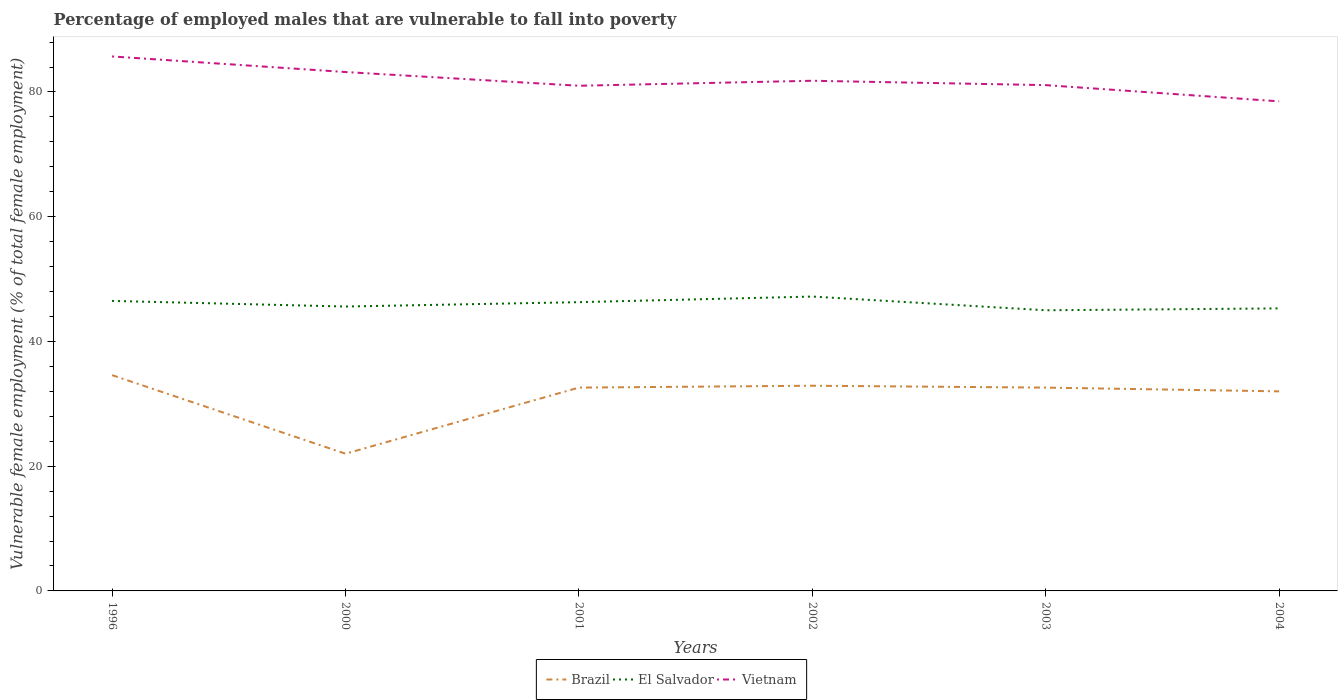How many different coloured lines are there?
Give a very brief answer. 3. Is the number of lines equal to the number of legend labels?
Ensure brevity in your answer.  Yes. In which year was the percentage of employed males who are vulnerable to fall into poverty in Brazil maximum?
Ensure brevity in your answer.  2000. What is the total percentage of employed males who are vulnerable to fall into poverty in Brazil in the graph?
Your answer should be very brief. -10.6. What is the difference between the highest and the second highest percentage of employed males who are vulnerable to fall into poverty in El Salvador?
Give a very brief answer. 2.2. What is the difference between the highest and the lowest percentage of employed males who are vulnerable to fall into poverty in El Salvador?
Provide a succinct answer. 3. How many lines are there?
Your answer should be very brief. 3. How many years are there in the graph?
Keep it short and to the point. 6. What is the difference between two consecutive major ticks on the Y-axis?
Your response must be concise. 20. Does the graph contain any zero values?
Your answer should be very brief. No. How many legend labels are there?
Ensure brevity in your answer.  3. How are the legend labels stacked?
Keep it short and to the point. Horizontal. What is the title of the graph?
Provide a short and direct response. Percentage of employed males that are vulnerable to fall into poverty. Does "Egypt, Arab Rep." appear as one of the legend labels in the graph?
Your answer should be compact. No. What is the label or title of the X-axis?
Provide a short and direct response. Years. What is the label or title of the Y-axis?
Offer a terse response. Vulnerable female employment (% of total female employment). What is the Vulnerable female employment (% of total female employment) of Brazil in 1996?
Your answer should be very brief. 34.6. What is the Vulnerable female employment (% of total female employment) of El Salvador in 1996?
Give a very brief answer. 46.5. What is the Vulnerable female employment (% of total female employment) in Vietnam in 1996?
Offer a terse response. 85.7. What is the Vulnerable female employment (% of total female employment) of Brazil in 2000?
Your answer should be very brief. 22. What is the Vulnerable female employment (% of total female employment) of El Salvador in 2000?
Your response must be concise. 45.6. What is the Vulnerable female employment (% of total female employment) of Vietnam in 2000?
Give a very brief answer. 83.2. What is the Vulnerable female employment (% of total female employment) of Brazil in 2001?
Provide a short and direct response. 32.6. What is the Vulnerable female employment (% of total female employment) in El Salvador in 2001?
Offer a terse response. 46.3. What is the Vulnerable female employment (% of total female employment) of Brazil in 2002?
Give a very brief answer. 32.9. What is the Vulnerable female employment (% of total female employment) of El Salvador in 2002?
Your answer should be compact. 47.2. What is the Vulnerable female employment (% of total female employment) of Vietnam in 2002?
Offer a very short reply. 81.8. What is the Vulnerable female employment (% of total female employment) of Brazil in 2003?
Provide a short and direct response. 32.6. What is the Vulnerable female employment (% of total female employment) in Vietnam in 2003?
Give a very brief answer. 81.1. What is the Vulnerable female employment (% of total female employment) in El Salvador in 2004?
Provide a short and direct response. 45.3. What is the Vulnerable female employment (% of total female employment) of Vietnam in 2004?
Offer a very short reply. 78.5. Across all years, what is the maximum Vulnerable female employment (% of total female employment) of Brazil?
Provide a succinct answer. 34.6. Across all years, what is the maximum Vulnerable female employment (% of total female employment) of El Salvador?
Your answer should be very brief. 47.2. Across all years, what is the maximum Vulnerable female employment (% of total female employment) in Vietnam?
Provide a short and direct response. 85.7. Across all years, what is the minimum Vulnerable female employment (% of total female employment) in Brazil?
Your answer should be compact. 22. Across all years, what is the minimum Vulnerable female employment (% of total female employment) of Vietnam?
Ensure brevity in your answer.  78.5. What is the total Vulnerable female employment (% of total female employment) in Brazil in the graph?
Make the answer very short. 186.7. What is the total Vulnerable female employment (% of total female employment) of El Salvador in the graph?
Your response must be concise. 275.9. What is the total Vulnerable female employment (% of total female employment) of Vietnam in the graph?
Give a very brief answer. 491.3. What is the difference between the Vulnerable female employment (% of total female employment) of Vietnam in 1996 and that in 2000?
Your answer should be compact. 2.5. What is the difference between the Vulnerable female employment (% of total female employment) of Vietnam in 1996 and that in 2001?
Give a very brief answer. 4.7. What is the difference between the Vulnerable female employment (% of total female employment) in Brazil in 1996 and that in 2002?
Provide a short and direct response. 1.7. What is the difference between the Vulnerable female employment (% of total female employment) in El Salvador in 1996 and that in 2003?
Your response must be concise. 1.5. What is the difference between the Vulnerable female employment (% of total female employment) of El Salvador in 1996 and that in 2004?
Give a very brief answer. 1.2. What is the difference between the Vulnerable female employment (% of total female employment) in El Salvador in 2000 and that in 2001?
Your response must be concise. -0.7. What is the difference between the Vulnerable female employment (% of total female employment) in Vietnam in 2000 and that in 2001?
Offer a terse response. 2.2. What is the difference between the Vulnerable female employment (% of total female employment) of Brazil in 2000 and that in 2002?
Keep it short and to the point. -10.9. What is the difference between the Vulnerable female employment (% of total female employment) in Vietnam in 2000 and that in 2002?
Offer a terse response. 1.4. What is the difference between the Vulnerable female employment (% of total female employment) of El Salvador in 2000 and that in 2003?
Make the answer very short. 0.6. What is the difference between the Vulnerable female employment (% of total female employment) of Vietnam in 2000 and that in 2003?
Offer a very short reply. 2.1. What is the difference between the Vulnerable female employment (% of total female employment) of Brazil in 2000 and that in 2004?
Your answer should be very brief. -10. What is the difference between the Vulnerable female employment (% of total female employment) in Brazil in 2001 and that in 2002?
Provide a succinct answer. -0.3. What is the difference between the Vulnerable female employment (% of total female employment) of Brazil in 2001 and that in 2003?
Offer a very short reply. 0. What is the difference between the Vulnerable female employment (% of total female employment) of El Salvador in 2001 and that in 2003?
Your response must be concise. 1.3. What is the difference between the Vulnerable female employment (% of total female employment) of El Salvador in 2001 and that in 2004?
Your answer should be very brief. 1. What is the difference between the Vulnerable female employment (% of total female employment) of El Salvador in 2002 and that in 2003?
Ensure brevity in your answer.  2.2. What is the difference between the Vulnerable female employment (% of total female employment) of El Salvador in 2002 and that in 2004?
Your answer should be compact. 1.9. What is the difference between the Vulnerable female employment (% of total female employment) in Vietnam in 2002 and that in 2004?
Ensure brevity in your answer.  3.3. What is the difference between the Vulnerable female employment (% of total female employment) in Brazil in 2003 and that in 2004?
Provide a short and direct response. 0.6. What is the difference between the Vulnerable female employment (% of total female employment) of Brazil in 1996 and the Vulnerable female employment (% of total female employment) of El Salvador in 2000?
Give a very brief answer. -11. What is the difference between the Vulnerable female employment (% of total female employment) of Brazil in 1996 and the Vulnerable female employment (% of total female employment) of Vietnam in 2000?
Offer a very short reply. -48.6. What is the difference between the Vulnerable female employment (% of total female employment) in El Salvador in 1996 and the Vulnerable female employment (% of total female employment) in Vietnam in 2000?
Offer a terse response. -36.7. What is the difference between the Vulnerable female employment (% of total female employment) in Brazil in 1996 and the Vulnerable female employment (% of total female employment) in Vietnam in 2001?
Keep it short and to the point. -46.4. What is the difference between the Vulnerable female employment (% of total female employment) of El Salvador in 1996 and the Vulnerable female employment (% of total female employment) of Vietnam in 2001?
Give a very brief answer. -34.5. What is the difference between the Vulnerable female employment (% of total female employment) of Brazil in 1996 and the Vulnerable female employment (% of total female employment) of El Salvador in 2002?
Make the answer very short. -12.6. What is the difference between the Vulnerable female employment (% of total female employment) in Brazil in 1996 and the Vulnerable female employment (% of total female employment) in Vietnam in 2002?
Make the answer very short. -47.2. What is the difference between the Vulnerable female employment (% of total female employment) of El Salvador in 1996 and the Vulnerable female employment (% of total female employment) of Vietnam in 2002?
Provide a short and direct response. -35.3. What is the difference between the Vulnerable female employment (% of total female employment) in Brazil in 1996 and the Vulnerable female employment (% of total female employment) in El Salvador in 2003?
Provide a succinct answer. -10.4. What is the difference between the Vulnerable female employment (% of total female employment) of Brazil in 1996 and the Vulnerable female employment (% of total female employment) of Vietnam in 2003?
Provide a succinct answer. -46.5. What is the difference between the Vulnerable female employment (% of total female employment) in El Salvador in 1996 and the Vulnerable female employment (% of total female employment) in Vietnam in 2003?
Make the answer very short. -34.6. What is the difference between the Vulnerable female employment (% of total female employment) in Brazil in 1996 and the Vulnerable female employment (% of total female employment) in Vietnam in 2004?
Offer a very short reply. -43.9. What is the difference between the Vulnerable female employment (% of total female employment) of El Salvador in 1996 and the Vulnerable female employment (% of total female employment) of Vietnam in 2004?
Offer a terse response. -32. What is the difference between the Vulnerable female employment (% of total female employment) in Brazil in 2000 and the Vulnerable female employment (% of total female employment) in El Salvador in 2001?
Your answer should be compact. -24.3. What is the difference between the Vulnerable female employment (% of total female employment) of Brazil in 2000 and the Vulnerable female employment (% of total female employment) of Vietnam in 2001?
Keep it short and to the point. -59. What is the difference between the Vulnerable female employment (% of total female employment) in El Salvador in 2000 and the Vulnerable female employment (% of total female employment) in Vietnam in 2001?
Give a very brief answer. -35.4. What is the difference between the Vulnerable female employment (% of total female employment) of Brazil in 2000 and the Vulnerable female employment (% of total female employment) of El Salvador in 2002?
Your answer should be compact. -25.2. What is the difference between the Vulnerable female employment (% of total female employment) of Brazil in 2000 and the Vulnerable female employment (% of total female employment) of Vietnam in 2002?
Your answer should be compact. -59.8. What is the difference between the Vulnerable female employment (% of total female employment) of El Salvador in 2000 and the Vulnerable female employment (% of total female employment) of Vietnam in 2002?
Give a very brief answer. -36.2. What is the difference between the Vulnerable female employment (% of total female employment) in Brazil in 2000 and the Vulnerable female employment (% of total female employment) in Vietnam in 2003?
Offer a very short reply. -59.1. What is the difference between the Vulnerable female employment (% of total female employment) in El Salvador in 2000 and the Vulnerable female employment (% of total female employment) in Vietnam in 2003?
Keep it short and to the point. -35.5. What is the difference between the Vulnerable female employment (% of total female employment) of Brazil in 2000 and the Vulnerable female employment (% of total female employment) of El Salvador in 2004?
Keep it short and to the point. -23.3. What is the difference between the Vulnerable female employment (% of total female employment) in Brazil in 2000 and the Vulnerable female employment (% of total female employment) in Vietnam in 2004?
Provide a short and direct response. -56.5. What is the difference between the Vulnerable female employment (% of total female employment) of El Salvador in 2000 and the Vulnerable female employment (% of total female employment) of Vietnam in 2004?
Keep it short and to the point. -32.9. What is the difference between the Vulnerable female employment (% of total female employment) in Brazil in 2001 and the Vulnerable female employment (% of total female employment) in El Salvador in 2002?
Provide a short and direct response. -14.6. What is the difference between the Vulnerable female employment (% of total female employment) of Brazil in 2001 and the Vulnerable female employment (% of total female employment) of Vietnam in 2002?
Provide a succinct answer. -49.2. What is the difference between the Vulnerable female employment (% of total female employment) in El Salvador in 2001 and the Vulnerable female employment (% of total female employment) in Vietnam in 2002?
Your response must be concise. -35.5. What is the difference between the Vulnerable female employment (% of total female employment) of Brazil in 2001 and the Vulnerable female employment (% of total female employment) of El Salvador in 2003?
Provide a succinct answer. -12.4. What is the difference between the Vulnerable female employment (% of total female employment) of Brazil in 2001 and the Vulnerable female employment (% of total female employment) of Vietnam in 2003?
Provide a short and direct response. -48.5. What is the difference between the Vulnerable female employment (% of total female employment) in El Salvador in 2001 and the Vulnerable female employment (% of total female employment) in Vietnam in 2003?
Your answer should be very brief. -34.8. What is the difference between the Vulnerable female employment (% of total female employment) in Brazil in 2001 and the Vulnerable female employment (% of total female employment) in El Salvador in 2004?
Offer a terse response. -12.7. What is the difference between the Vulnerable female employment (% of total female employment) of Brazil in 2001 and the Vulnerable female employment (% of total female employment) of Vietnam in 2004?
Ensure brevity in your answer.  -45.9. What is the difference between the Vulnerable female employment (% of total female employment) of El Salvador in 2001 and the Vulnerable female employment (% of total female employment) of Vietnam in 2004?
Provide a short and direct response. -32.2. What is the difference between the Vulnerable female employment (% of total female employment) in Brazil in 2002 and the Vulnerable female employment (% of total female employment) in Vietnam in 2003?
Provide a succinct answer. -48.2. What is the difference between the Vulnerable female employment (% of total female employment) of El Salvador in 2002 and the Vulnerable female employment (% of total female employment) of Vietnam in 2003?
Ensure brevity in your answer.  -33.9. What is the difference between the Vulnerable female employment (% of total female employment) of Brazil in 2002 and the Vulnerable female employment (% of total female employment) of El Salvador in 2004?
Offer a very short reply. -12.4. What is the difference between the Vulnerable female employment (% of total female employment) in Brazil in 2002 and the Vulnerable female employment (% of total female employment) in Vietnam in 2004?
Provide a succinct answer. -45.6. What is the difference between the Vulnerable female employment (% of total female employment) in El Salvador in 2002 and the Vulnerable female employment (% of total female employment) in Vietnam in 2004?
Your response must be concise. -31.3. What is the difference between the Vulnerable female employment (% of total female employment) of Brazil in 2003 and the Vulnerable female employment (% of total female employment) of El Salvador in 2004?
Your answer should be very brief. -12.7. What is the difference between the Vulnerable female employment (% of total female employment) in Brazil in 2003 and the Vulnerable female employment (% of total female employment) in Vietnam in 2004?
Keep it short and to the point. -45.9. What is the difference between the Vulnerable female employment (% of total female employment) in El Salvador in 2003 and the Vulnerable female employment (% of total female employment) in Vietnam in 2004?
Your answer should be very brief. -33.5. What is the average Vulnerable female employment (% of total female employment) in Brazil per year?
Your answer should be very brief. 31.12. What is the average Vulnerable female employment (% of total female employment) of El Salvador per year?
Offer a terse response. 45.98. What is the average Vulnerable female employment (% of total female employment) in Vietnam per year?
Your answer should be compact. 81.88. In the year 1996, what is the difference between the Vulnerable female employment (% of total female employment) in Brazil and Vulnerable female employment (% of total female employment) in Vietnam?
Provide a succinct answer. -51.1. In the year 1996, what is the difference between the Vulnerable female employment (% of total female employment) in El Salvador and Vulnerable female employment (% of total female employment) in Vietnam?
Provide a succinct answer. -39.2. In the year 2000, what is the difference between the Vulnerable female employment (% of total female employment) in Brazil and Vulnerable female employment (% of total female employment) in El Salvador?
Ensure brevity in your answer.  -23.6. In the year 2000, what is the difference between the Vulnerable female employment (% of total female employment) of Brazil and Vulnerable female employment (% of total female employment) of Vietnam?
Make the answer very short. -61.2. In the year 2000, what is the difference between the Vulnerable female employment (% of total female employment) of El Salvador and Vulnerable female employment (% of total female employment) of Vietnam?
Offer a very short reply. -37.6. In the year 2001, what is the difference between the Vulnerable female employment (% of total female employment) in Brazil and Vulnerable female employment (% of total female employment) in El Salvador?
Keep it short and to the point. -13.7. In the year 2001, what is the difference between the Vulnerable female employment (% of total female employment) of Brazil and Vulnerable female employment (% of total female employment) of Vietnam?
Offer a terse response. -48.4. In the year 2001, what is the difference between the Vulnerable female employment (% of total female employment) of El Salvador and Vulnerable female employment (% of total female employment) of Vietnam?
Offer a terse response. -34.7. In the year 2002, what is the difference between the Vulnerable female employment (% of total female employment) in Brazil and Vulnerable female employment (% of total female employment) in El Salvador?
Provide a succinct answer. -14.3. In the year 2002, what is the difference between the Vulnerable female employment (% of total female employment) in Brazil and Vulnerable female employment (% of total female employment) in Vietnam?
Keep it short and to the point. -48.9. In the year 2002, what is the difference between the Vulnerable female employment (% of total female employment) of El Salvador and Vulnerable female employment (% of total female employment) of Vietnam?
Offer a terse response. -34.6. In the year 2003, what is the difference between the Vulnerable female employment (% of total female employment) in Brazil and Vulnerable female employment (% of total female employment) in El Salvador?
Provide a short and direct response. -12.4. In the year 2003, what is the difference between the Vulnerable female employment (% of total female employment) of Brazil and Vulnerable female employment (% of total female employment) of Vietnam?
Make the answer very short. -48.5. In the year 2003, what is the difference between the Vulnerable female employment (% of total female employment) of El Salvador and Vulnerable female employment (% of total female employment) of Vietnam?
Your answer should be very brief. -36.1. In the year 2004, what is the difference between the Vulnerable female employment (% of total female employment) of Brazil and Vulnerable female employment (% of total female employment) of Vietnam?
Your answer should be compact. -46.5. In the year 2004, what is the difference between the Vulnerable female employment (% of total female employment) in El Salvador and Vulnerable female employment (% of total female employment) in Vietnam?
Offer a very short reply. -33.2. What is the ratio of the Vulnerable female employment (% of total female employment) in Brazil in 1996 to that in 2000?
Provide a succinct answer. 1.57. What is the ratio of the Vulnerable female employment (% of total female employment) of El Salvador in 1996 to that in 2000?
Provide a succinct answer. 1.02. What is the ratio of the Vulnerable female employment (% of total female employment) of Vietnam in 1996 to that in 2000?
Offer a terse response. 1.03. What is the ratio of the Vulnerable female employment (% of total female employment) of Brazil in 1996 to that in 2001?
Ensure brevity in your answer.  1.06. What is the ratio of the Vulnerable female employment (% of total female employment) in Vietnam in 1996 to that in 2001?
Your answer should be compact. 1.06. What is the ratio of the Vulnerable female employment (% of total female employment) of Brazil in 1996 to that in 2002?
Ensure brevity in your answer.  1.05. What is the ratio of the Vulnerable female employment (% of total female employment) of El Salvador in 1996 to that in 2002?
Your response must be concise. 0.99. What is the ratio of the Vulnerable female employment (% of total female employment) of Vietnam in 1996 to that in 2002?
Provide a succinct answer. 1.05. What is the ratio of the Vulnerable female employment (% of total female employment) of Brazil in 1996 to that in 2003?
Offer a terse response. 1.06. What is the ratio of the Vulnerable female employment (% of total female employment) in El Salvador in 1996 to that in 2003?
Keep it short and to the point. 1.03. What is the ratio of the Vulnerable female employment (% of total female employment) of Vietnam in 1996 to that in 2003?
Offer a terse response. 1.06. What is the ratio of the Vulnerable female employment (% of total female employment) in Brazil in 1996 to that in 2004?
Offer a terse response. 1.08. What is the ratio of the Vulnerable female employment (% of total female employment) in El Salvador in 1996 to that in 2004?
Provide a succinct answer. 1.03. What is the ratio of the Vulnerable female employment (% of total female employment) in Vietnam in 1996 to that in 2004?
Your answer should be compact. 1.09. What is the ratio of the Vulnerable female employment (% of total female employment) of Brazil in 2000 to that in 2001?
Offer a very short reply. 0.67. What is the ratio of the Vulnerable female employment (% of total female employment) in El Salvador in 2000 to that in 2001?
Make the answer very short. 0.98. What is the ratio of the Vulnerable female employment (% of total female employment) in Vietnam in 2000 to that in 2001?
Provide a succinct answer. 1.03. What is the ratio of the Vulnerable female employment (% of total female employment) of Brazil in 2000 to that in 2002?
Offer a terse response. 0.67. What is the ratio of the Vulnerable female employment (% of total female employment) in El Salvador in 2000 to that in 2002?
Your answer should be compact. 0.97. What is the ratio of the Vulnerable female employment (% of total female employment) of Vietnam in 2000 to that in 2002?
Offer a terse response. 1.02. What is the ratio of the Vulnerable female employment (% of total female employment) of Brazil in 2000 to that in 2003?
Ensure brevity in your answer.  0.67. What is the ratio of the Vulnerable female employment (% of total female employment) of El Salvador in 2000 to that in 2003?
Ensure brevity in your answer.  1.01. What is the ratio of the Vulnerable female employment (% of total female employment) in Vietnam in 2000 to that in 2003?
Offer a terse response. 1.03. What is the ratio of the Vulnerable female employment (% of total female employment) in Brazil in 2000 to that in 2004?
Keep it short and to the point. 0.69. What is the ratio of the Vulnerable female employment (% of total female employment) of El Salvador in 2000 to that in 2004?
Provide a succinct answer. 1.01. What is the ratio of the Vulnerable female employment (% of total female employment) of Vietnam in 2000 to that in 2004?
Provide a succinct answer. 1.06. What is the ratio of the Vulnerable female employment (% of total female employment) of Brazil in 2001 to that in 2002?
Ensure brevity in your answer.  0.99. What is the ratio of the Vulnerable female employment (% of total female employment) in El Salvador in 2001 to that in 2002?
Make the answer very short. 0.98. What is the ratio of the Vulnerable female employment (% of total female employment) of Vietnam in 2001 to that in 2002?
Make the answer very short. 0.99. What is the ratio of the Vulnerable female employment (% of total female employment) in Brazil in 2001 to that in 2003?
Provide a short and direct response. 1. What is the ratio of the Vulnerable female employment (% of total female employment) of El Salvador in 2001 to that in 2003?
Your response must be concise. 1.03. What is the ratio of the Vulnerable female employment (% of total female employment) of Vietnam in 2001 to that in 2003?
Your answer should be very brief. 1. What is the ratio of the Vulnerable female employment (% of total female employment) of Brazil in 2001 to that in 2004?
Give a very brief answer. 1.02. What is the ratio of the Vulnerable female employment (% of total female employment) in El Salvador in 2001 to that in 2004?
Provide a succinct answer. 1.02. What is the ratio of the Vulnerable female employment (% of total female employment) of Vietnam in 2001 to that in 2004?
Provide a succinct answer. 1.03. What is the ratio of the Vulnerable female employment (% of total female employment) of Brazil in 2002 to that in 2003?
Provide a succinct answer. 1.01. What is the ratio of the Vulnerable female employment (% of total female employment) of El Salvador in 2002 to that in 2003?
Your response must be concise. 1.05. What is the ratio of the Vulnerable female employment (% of total female employment) in Vietnam in 2002 to that in 2003?
Your answer should be very brief. 1.01. What is the ratio of the Vulnerable female employment (% of total female employment) in Brazil in 2002 to that in 2004?
Your response must be concise. 1.03. What is the ratio of the Vulnerable female employment (% of total female employment) in El Salvador in 2002 to that in 2004?
Offer a very short reply. 1.04. What is the ratio of the Vulnerable female employment (% of total female employment) in Vietnam in 2002 to that in 2004?
Keep it short and to the point. 1.04. What is the ratio of the Vulnerable female employment (% of total female employment) in Brazil in 2003 to that in 2004?
Ensure brevity in your answer.  1.02. What is the ratio of the Vulnerable female employment (% of total female employment) of El Salvador in 2003 to that in 2004?
Provide a succinct answer. 0.99. What is the ratio of the Vulnerable female employment (% of total female employment) of Vietnam in 2003 to that in 2004?
Make the answer very short. 1.03. What is the difference between the highest and the second highest Vulnerable female employment (% of total female employment) in El Salvador?
Your answer should be compact. 0.7. What is the difference between the highest and the lowest Vulnerable female employment (% of total female employment) of Brazil?
Your answer should be very brief. 12.6. What is the difference between the highest and the lowest Vulnerable female employment (% of total female employment) of El Salvador?
Ensure brevity in your answer.  2.2. 